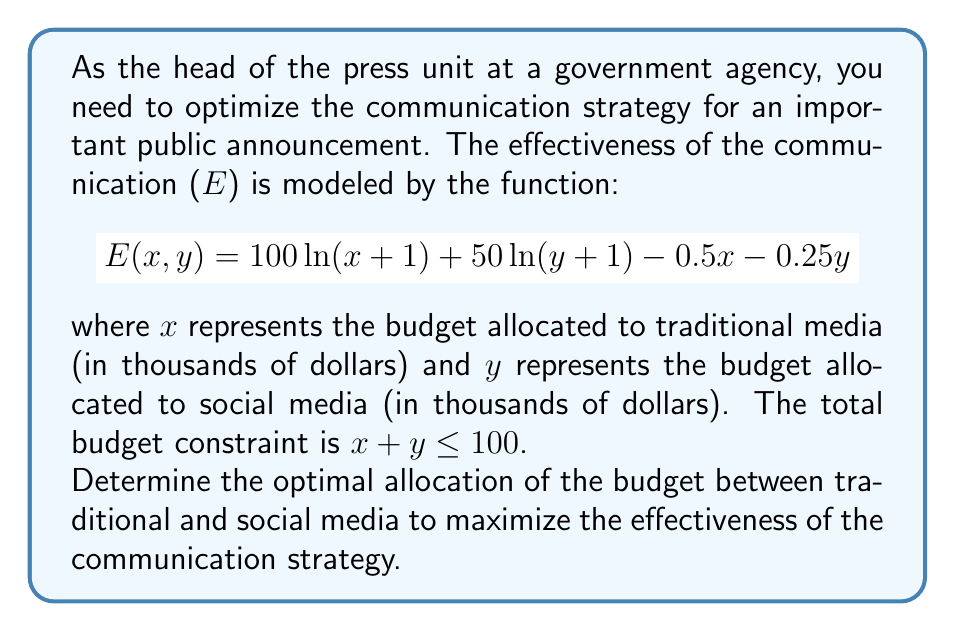Give your solution to this math problem. To solve this optimization problem, we'll use the method of Lagrange multipliers:

1) First, let's define the Lagrangian function:
   $$L(x, y, \lambda) = 100 \ln(x+1) + 50 \ln(y+1) - 0.5x - 0.25y + \lambda(100 - x - y)$$

2) Now, we'll take partial derivatives and set them to zero:

   $$\frac{\partial L}{\partial x} = \frac{100}{x+1} - 0.5 - \lambda = 0$$
   $$\frac{\partial L}{\partial y} = \frac{50}{y+1} - 0.25 - \lambda = 0$$
   $$\frac{\partial L}{\partial \lambda} = 100 - x - y = 0$$

3) From the first two equations:
   $$\frac{100}{x+1} - 0.5 = \frac{50}{y+1} - 0.25$$

4) Simplifying:
   $$\frac{100}{x+1} = \frac{50}{y+1} + 0.25$$
   $$200(y+1) = 100(x+1) + 0.25(x+1)(y+1)$$
   $$200y + 200 = 100x + 100 + 0.25xy + 0.25x + 0.25y + 0.25$$
   $$199.75y - 99.75x = 100.25$$

5) From the budget constraint:
   $$y = 100 - x$$

6) Substituting this into the equation from step 4:
   $$199.75(100-x) - 99.75x = 100.25$$
   $$19975 - 199.75x - 99.75x = 100.25$$
   $$19975 - 299.5x = 100.25$$
   $$19874.75 = 299.5x$$
   $$x \approx 66.36$$

7) Therefore:
   $$y \approx 33.64$$

8) To verify this is a maximum, we can check the second derivatives:
   $$\frac{\partial^2 E}{\partial x^2} = -\frac{100}{(x+1)^2} < 0$$
   $$\frac{\partial^2 E}{\partial y^2} = -\frac{50}{(y+1)^2} < 0$$

   These are both negative, confirming a maximum.
Answer: The optimal allocation to maximize communication effectiveness is approximately $66,360 for traditional media and $33,640 for social media. 